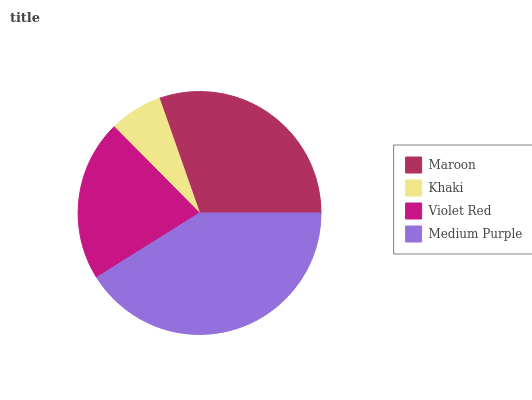Is Khaki the minimum?
Answer yes or no. Yes. Is Medium Purple the maximum?
Answer yes or no. Yes. Is Violet Red the minimum?
Answer yes or no. No. Is Violet Red the maximum?
Answer yes or no. No. Is Violet Red greater than Khaki?
Answer yes or no. Yes. Is Khaki less than Violet Red?
Answer yes or no. Yes. Is Khaki greater than Violet Red?
Answer yes or no. No. Is Violet Red less than Khaki?
Answer yes or no. No. Is Maroon the high median?
Answer yes or no. Yes. Is Violet Red the low median?
Answer yes or no. Yes. Is Khaki the high median?
Answer yes or no. No. Is Khaki the low median?
Answer yes or no. No. 